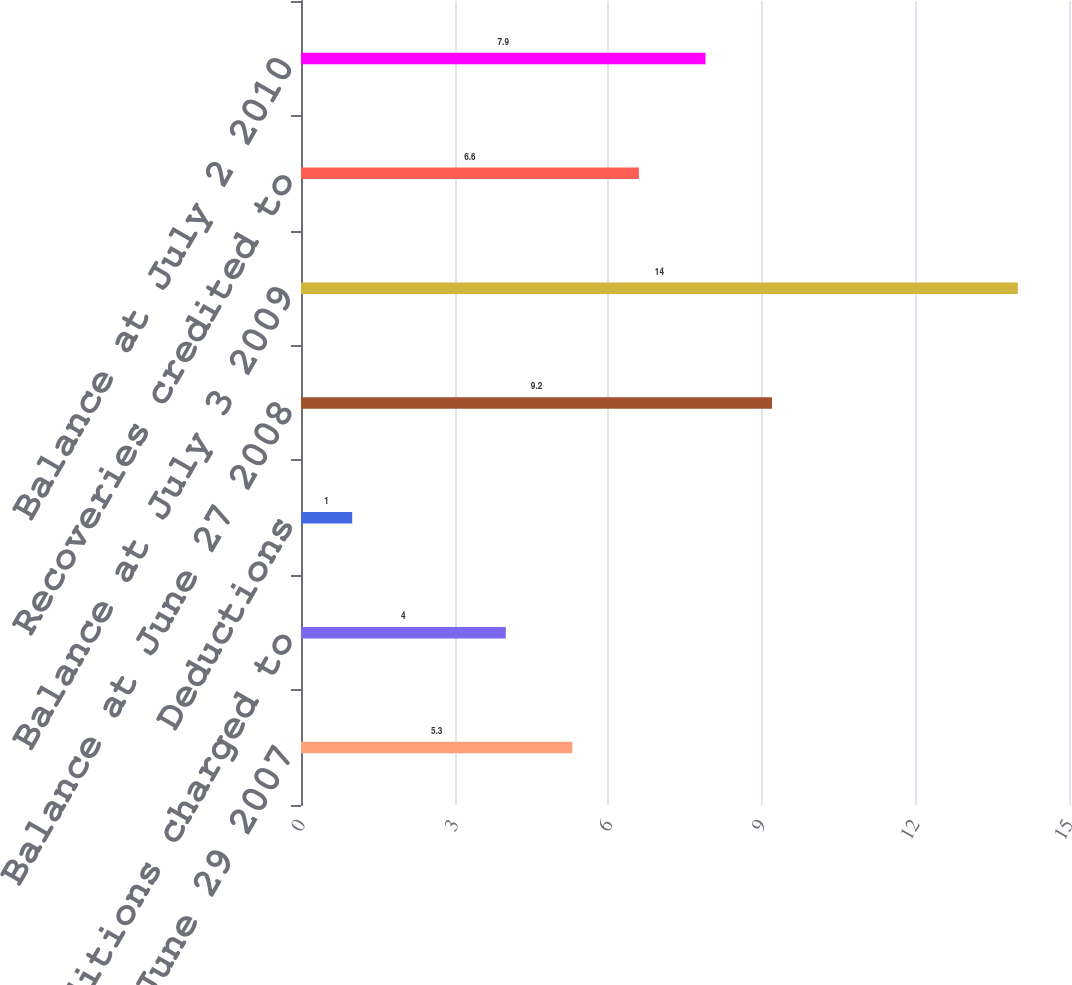<chart> <loc_0><loc_0><loc_500><loc_500><bar_chart><fcel>Balance at June 29 2007<fcel>Additions charged to<fcel>Deductions<fcel>Balance at June 27 2008<fcel>Balance at July 3 2009<fcel>Recoveries credited to<fcel>Balance at July 2 2010<nl><fcel>5.3<fcel>4<fcel>1<fcel>9.2<fcel>14<fcel>6.6<fcel>7.9<nl></chart> 